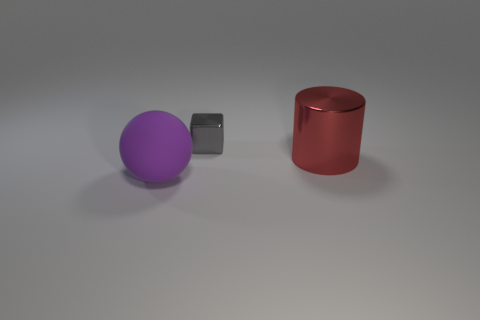Add 3 shiny cylinders. How many shiny cylinders are left? 4 Add 2 tiny green metallic things. How many tiny green metallic things exist? 2 Add 1 yellow matte spheres. How many objects exist? 4 Subtract 0 gray balls. How many objects are left? 3 Subtract all cylinders. How many objects are left? 2 Subtract 1 cylinders. How many cylinders are left? 0 Subtract all red blocks. Subtract all yellow balls. How many blocks are left? 1 Subtract all large blue metal cylinders. Subtract all cylinders. How many objects are left? 2 